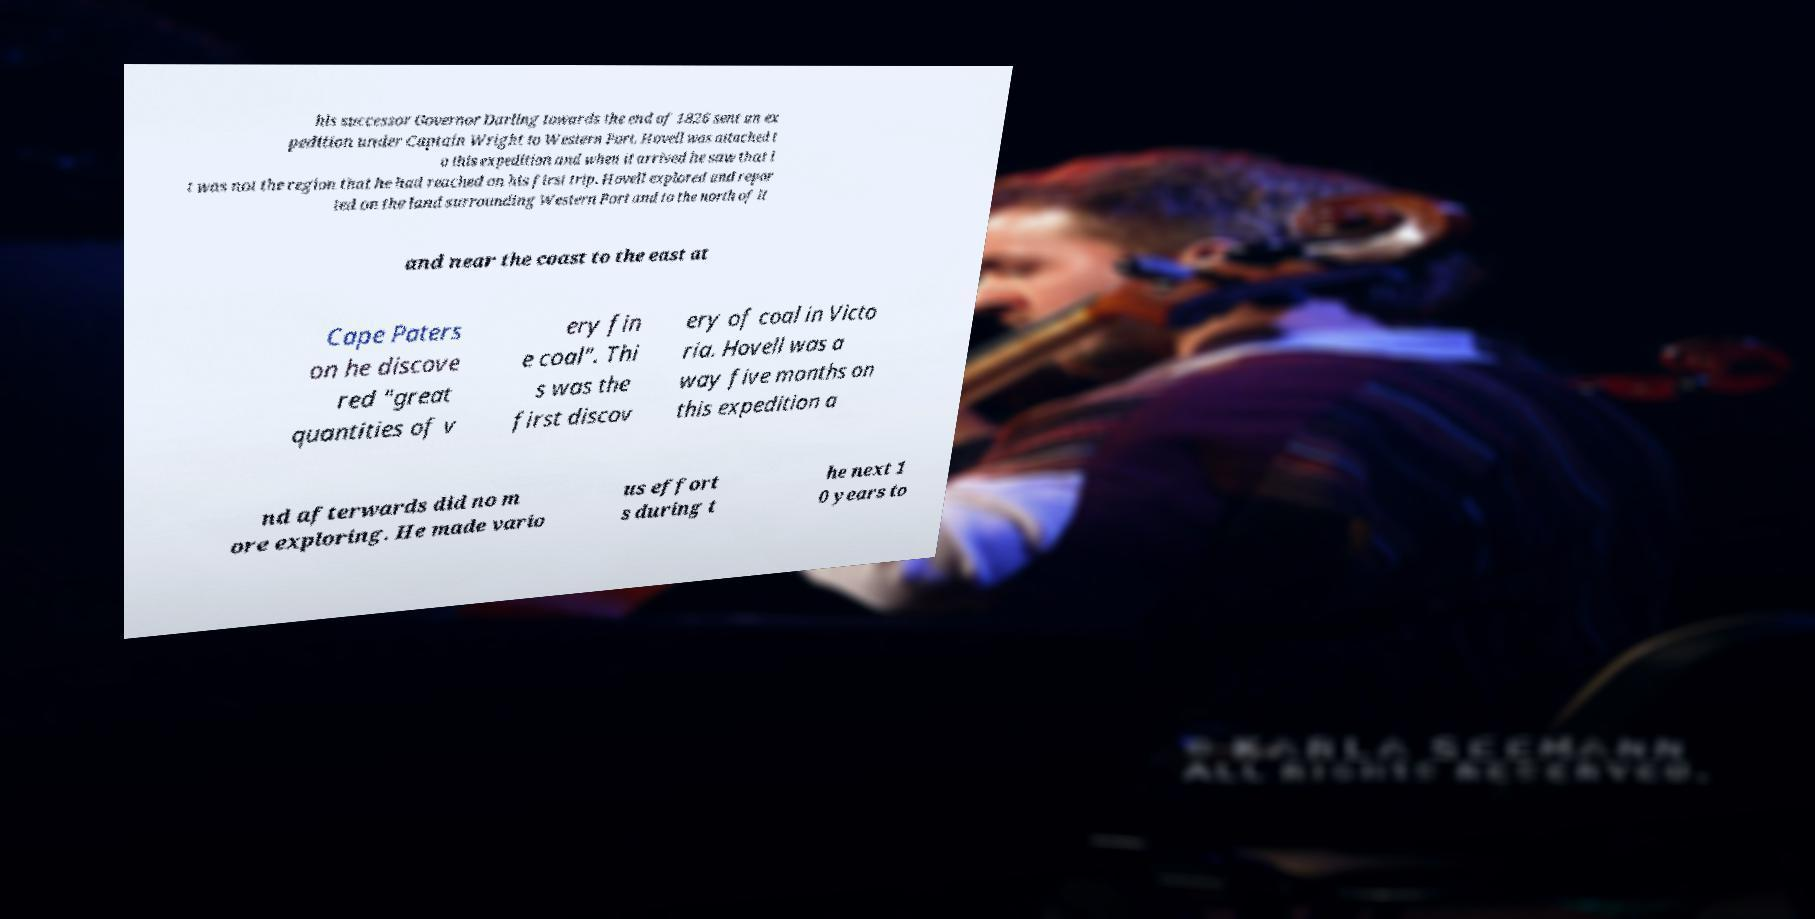What messages or text are displayed in this image? I need them in a readable, typed format. his successor Governor Darling towards the end of 1826 sent an ex pedition under Captain Wright to Western Port. Hovell was attached t o this expedition and when it arrived he saw that i t was not the region that he had reached on his first trip. Hovell explored and repor ted on the land surrounding Western Port and to the north of it and near the coast to the east at Cape Paters on he discove red "great quantities of v ery fin e coal". Thi s was the first discov ery of coal in Victo ria. Hovell was a way five months on this expedition a nd afterwards did no m ore exploring. He made vario us effort s during t he next 1 0 years to 